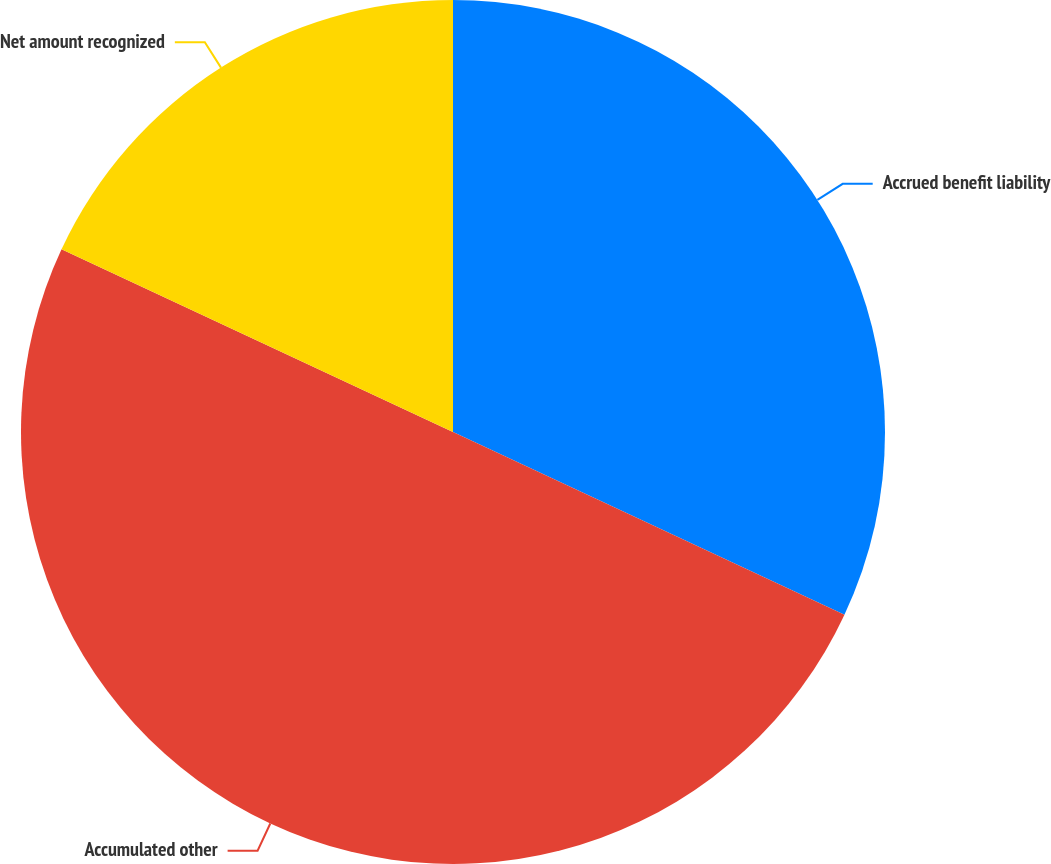<chart> <loc_0><loc_0><loc_500><loc_500><pie_chart><fcel>Accrued benefit liability<fcel>Accumulated other<fcel>Net amount recognized<nl><fcel>31.95%<fcel>50.0%<fcel>18.05%<nl></chart> 